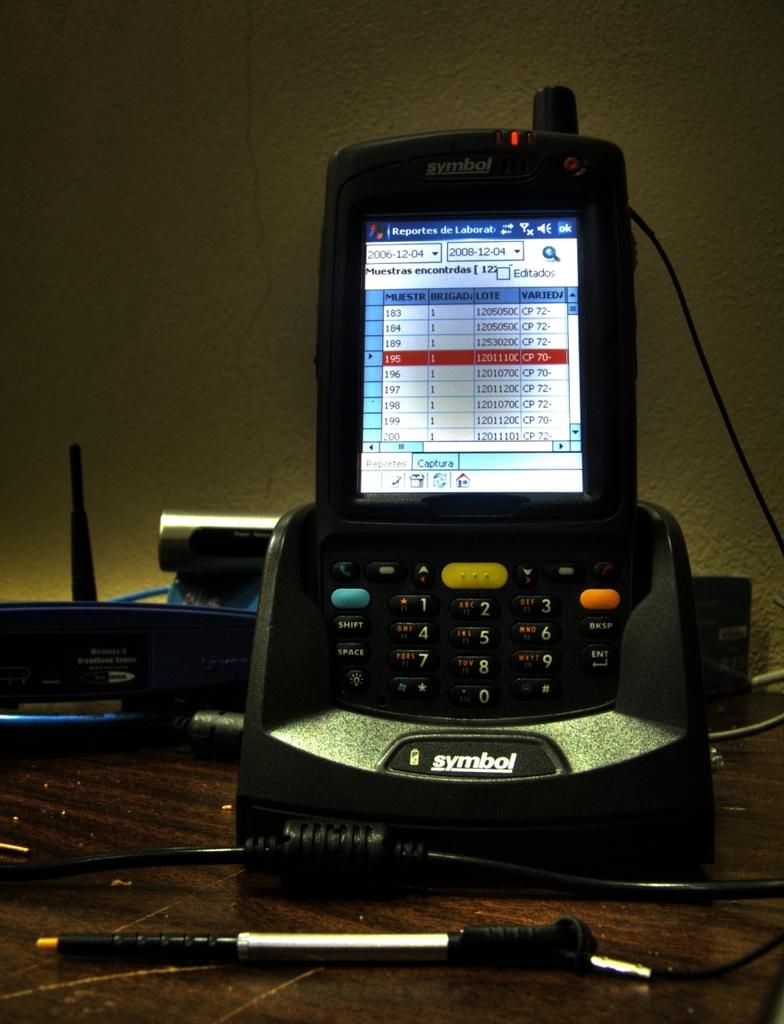Is that a type of machine by the company symbol?
Offer a terse response. Yes. What it is?
Provide a succinct answer. Symbol. 